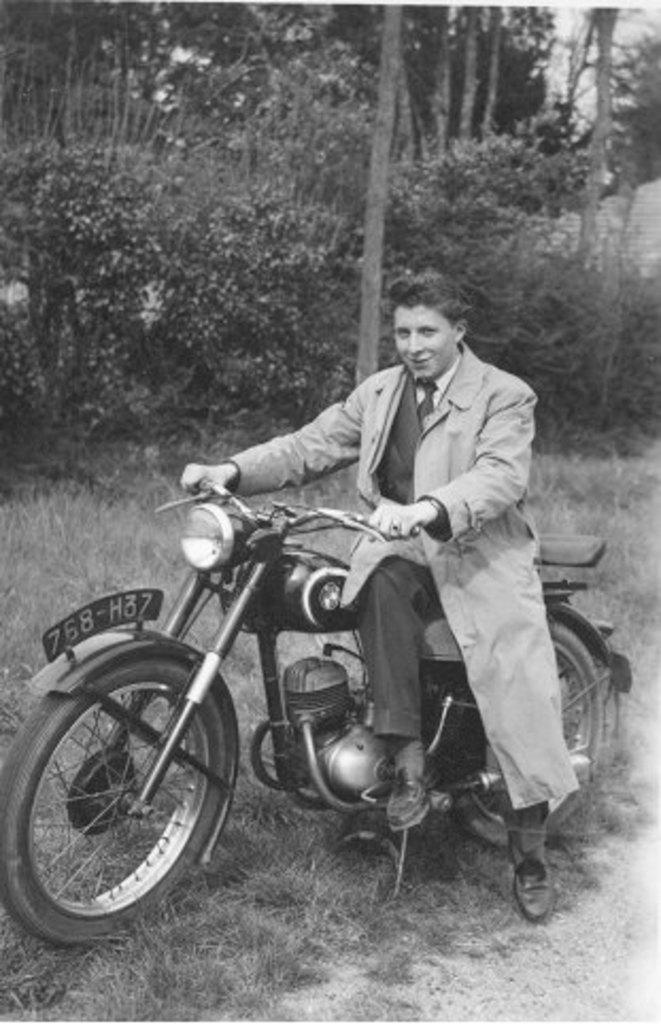What is the man in the image doing? The man is sitting on a motorbike in the image. What type of vegetation can be seen in the image? There is grass visible in the image. What other objects can be seen in the image besides the motorbike? There is a tree and a pole in the image. What language is the man speaking in the image? There is no indication of the man speaking in the image, nor is there any information about the language he might be speaking. 